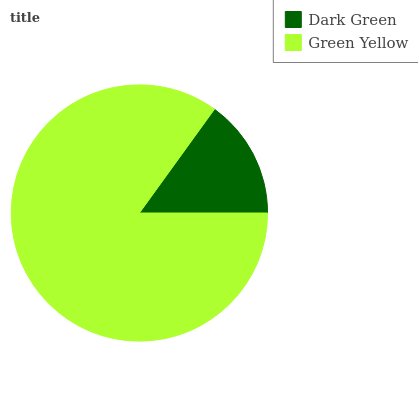Is Dark Green the minimum?
Answer yes or no. Yes. Is Green Yellow the maximum?
Answer yes or no. Yes. Is Green Yellow the minimum?
Answer yes or no. No. Is Green Yellow greater than Dark Green?
Answer yes or no. Yes. Is Dark Green less than Green Yellow?
Answer yes or no. Yes. Is Dark Green greater than Green Yellow?
Answer yes or no. No. Is Green Yellow less than Dark Green?
Answer yes or no. No. Is Green Yellow the high median?
Answer yes or no. Yes. Is Dark Green the low median?
Answer yes or no. Yes. Is Dark Green the high median?
Answer yes or no. No. Is Green Yellow the low median?
Answer yes or no. No. 